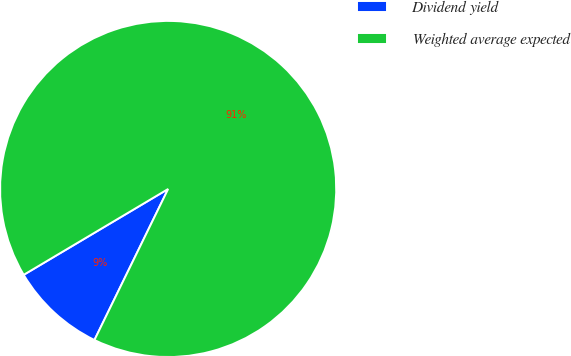Convert chart. <chart><loc_0><loc_0><loc_500><loc_500><pie_chart><fcel>Dividend yield<fcel>Weighted average expected<nl><fcel>9.24%<fcel>90.76%<nl></chart> 